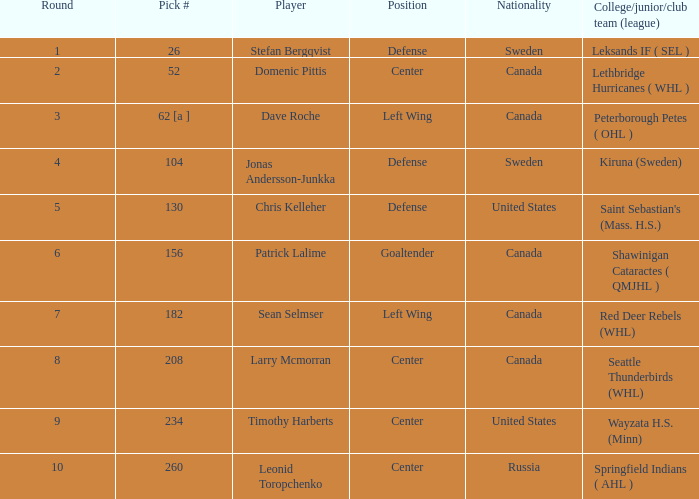What is the choice number for round 2? 52.0. 